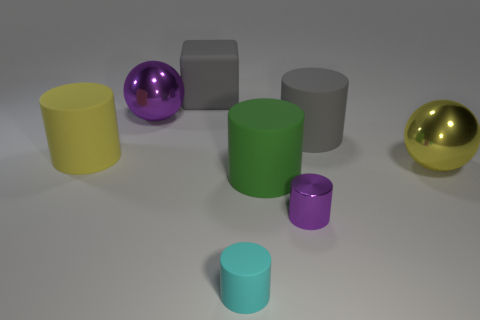Subtract 1 cylinders. How many cylinders are left? 4 Subtract all green cylinders. How many cylinders are left? 4 Subtract all purple metal cylinders. How many cylinders are left? 4 Add 2 big rubber objects. How many objects exist? 10 Subtract all cyan cylinders. Subtract all brown blocks. How many cylinders are left? 4 Subtract all cylinders. How many objects are left? 3 Add 6 large gray cylinders. How many large gray cylinders exist? 7 Subtract 0 brown spheres. How many objects are left? 8 Subtract all large yellow metallic spheres. Subtract all big blue shiny cubes. How many objects are left? 7 Add 4 matte things. How many matte things are left? 9 